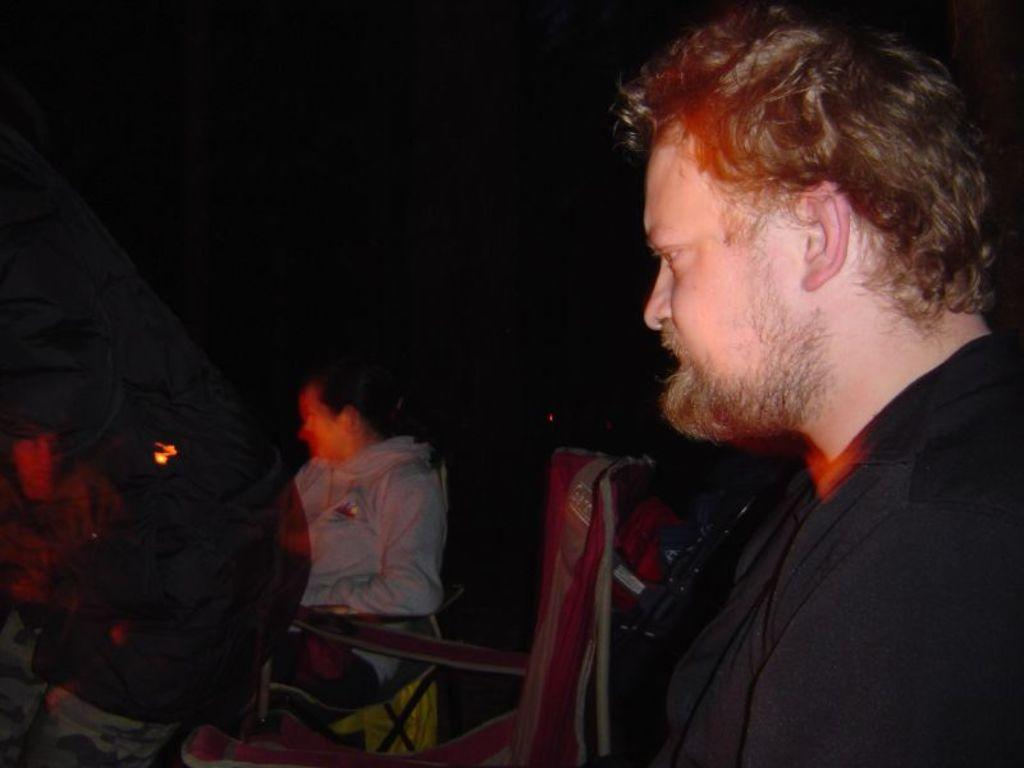How many people are in the image? There is a group of people in the image. What are some of the people in the image doing? Some people are seated, and some people are standing. Can you tell me how many beans are on the plate of the boy in the image? There is no boy or plate of beans present in the image. 